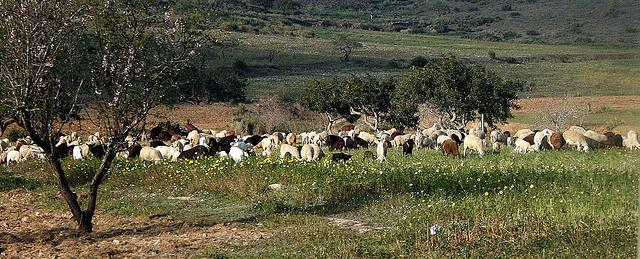What are the animals doing? grazing 